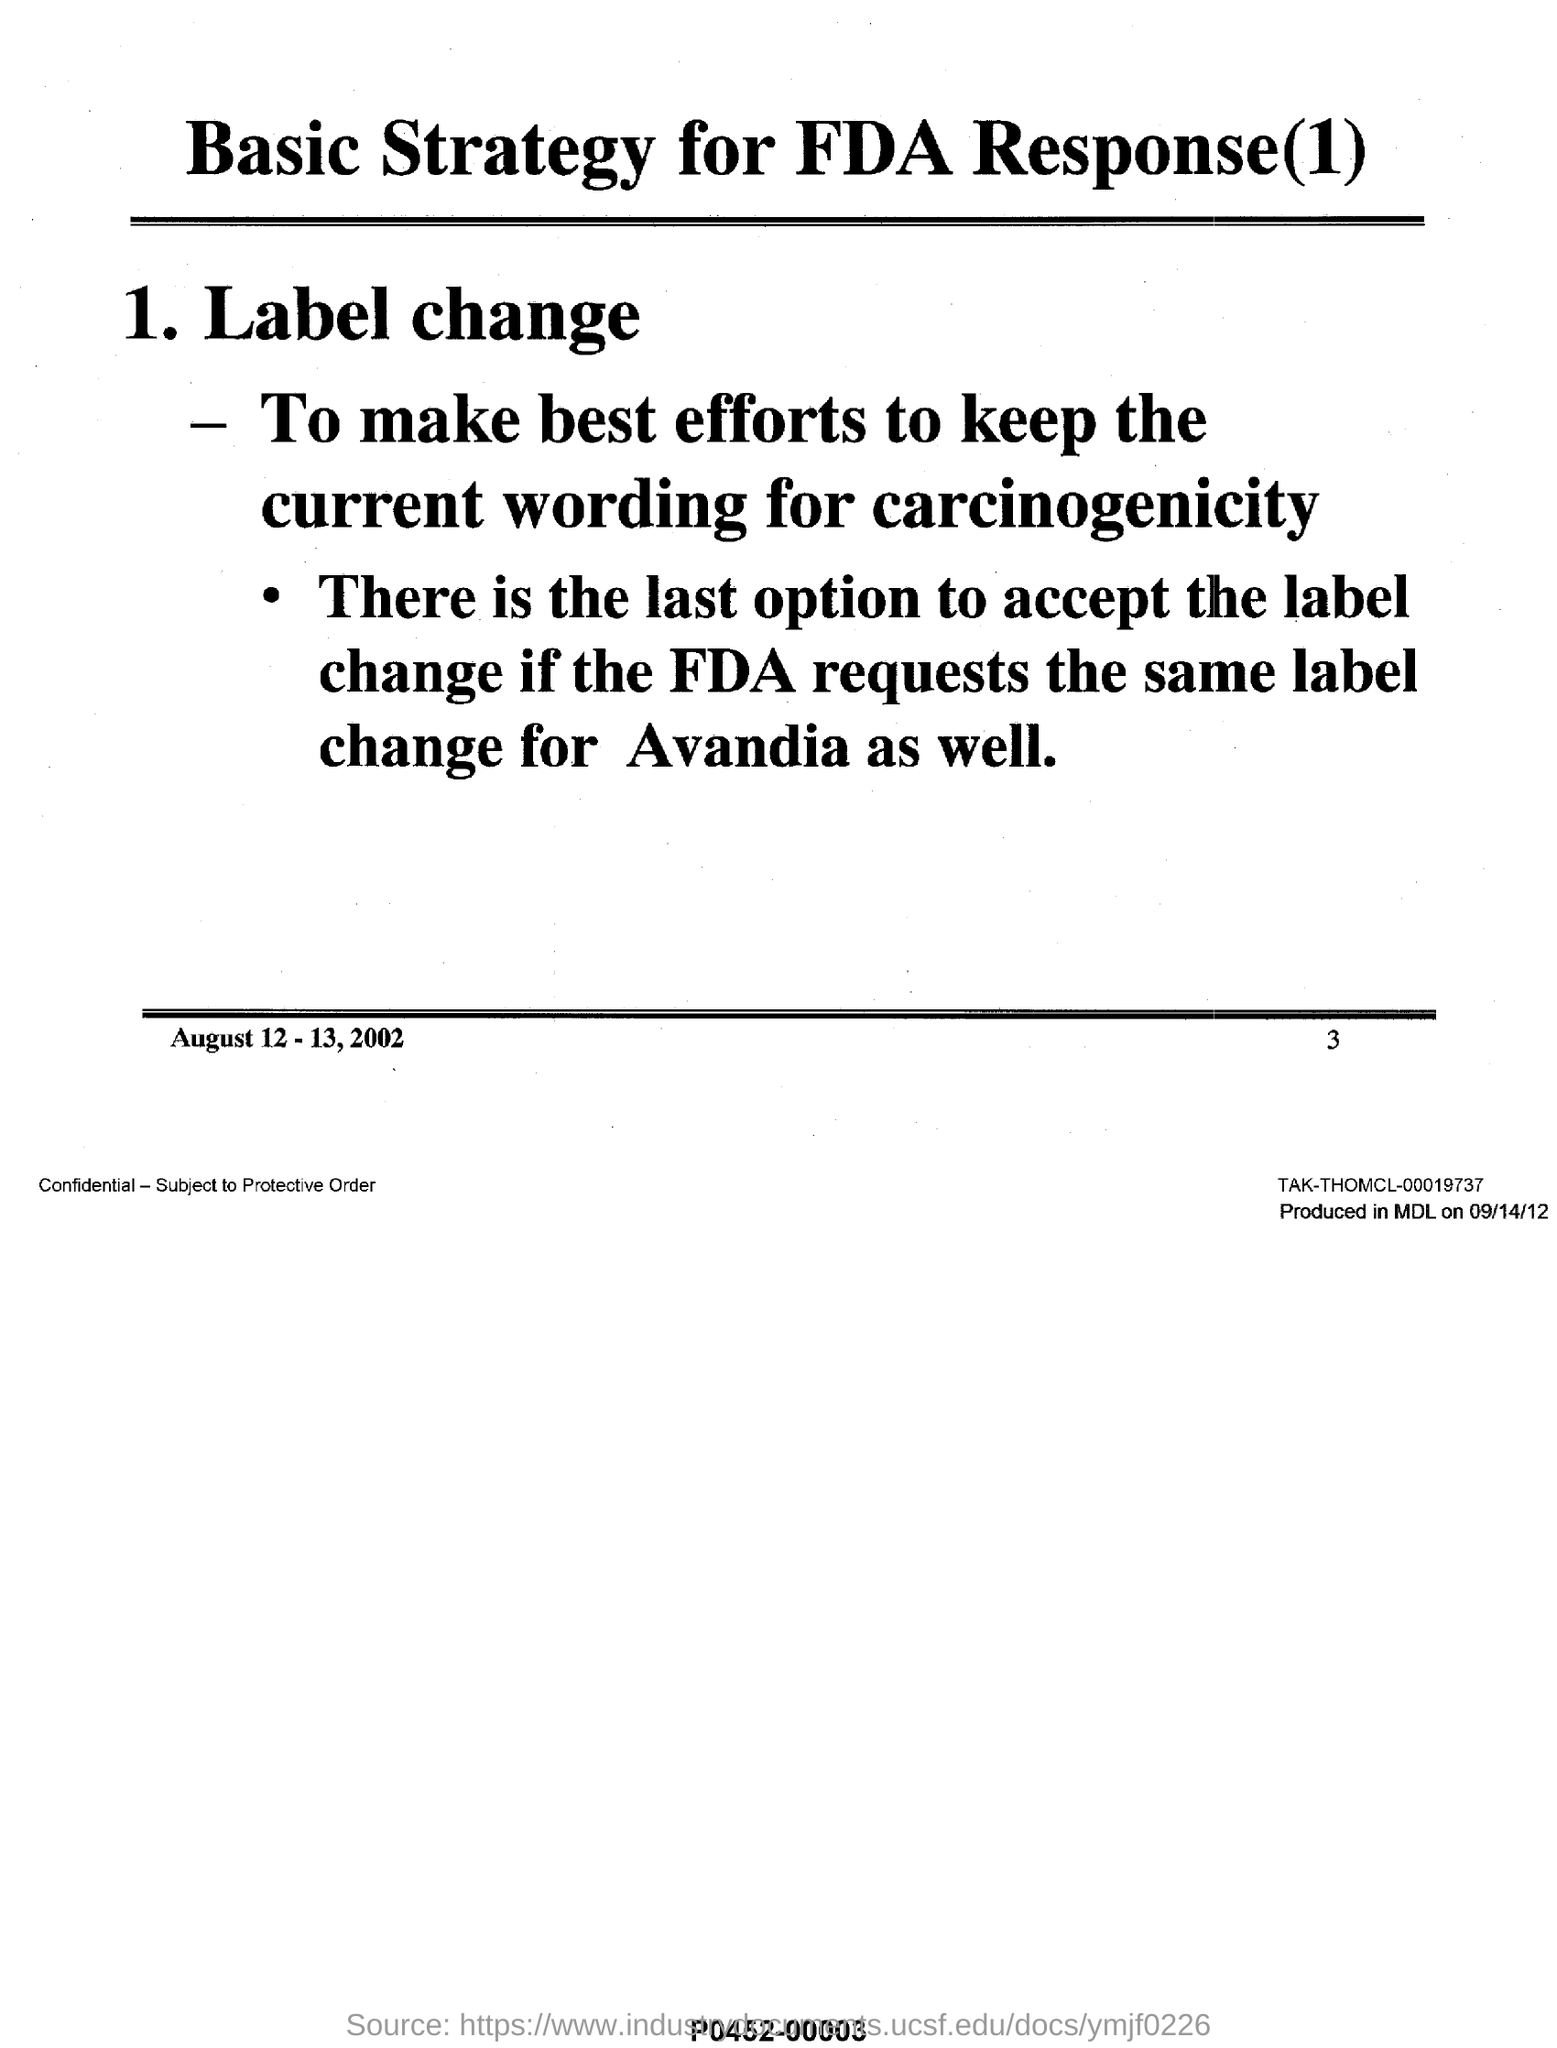What is the date mentioned in the document?
Give a very brief answer. August 12 - 13, 2002. What is the page number given at the footer?
Provide a succinct answer. 3. What is the heading of the document?
Provide a succinct answer. Basic Strategy for FDA Response(1). What is the first sub-heading in the document?
Give a very brief answer. 1. Label change. 